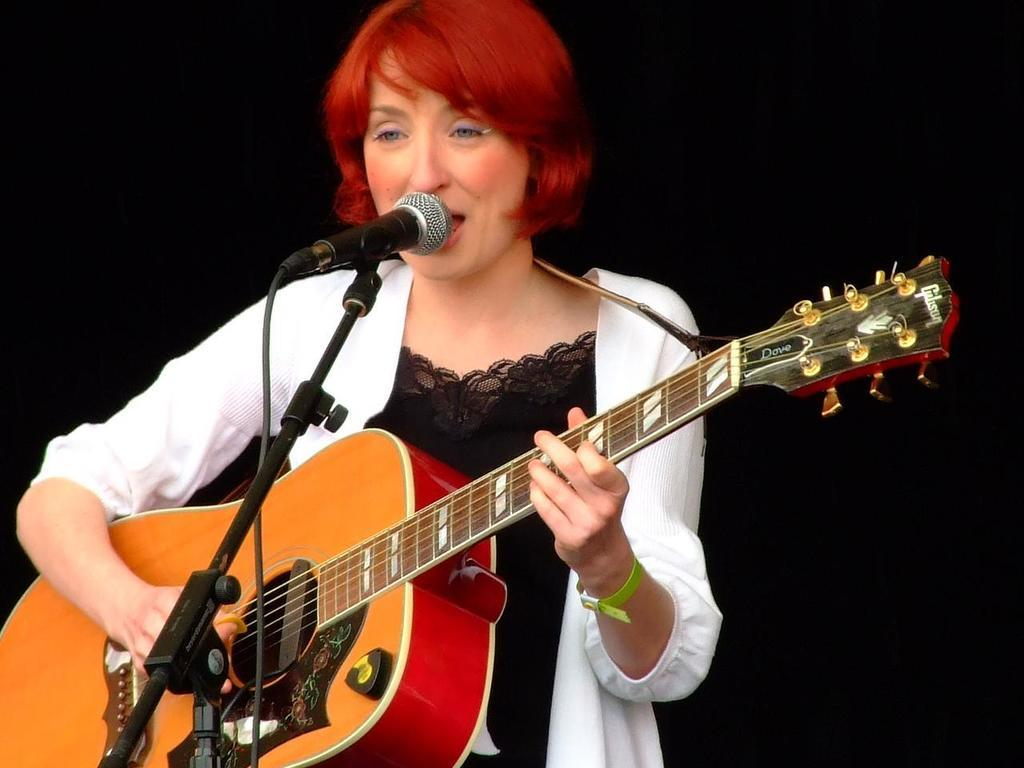Who is the main subject in the image? There is a lady in the center of the image. What is the lady doing in the image? The lady is singing in the image. What instrument is the lady holding? The lady is holding a guitar in the image. What device is in front of the lady? There is a microphone in front of the lady in the image. Can you hear the girl's voice in the image? The image is a still photograph, so it does not capture sound. Therefore, we cannot hear the girl's voice in the image. Is there a window visible in the image? There is no mention of a window in the provided facts, so we cannot determine if there is one in the image. 